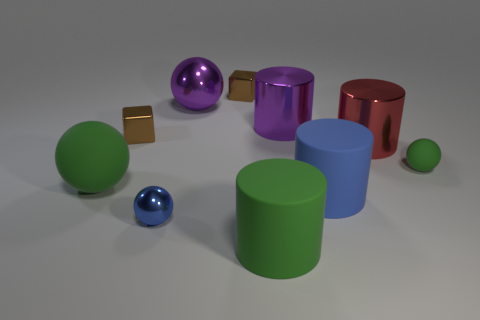There is a big cylinder that is the same color as the big shiny sphere; what material is it?
Make the answer very short. Metal. There is a object that is in front of the red thing and right of the blue cylinder; how big is it?
Give a very brief answer. Small. Is there a large cylinder in front of the green matte ball in front of the green rubber ball to the right of the blue metallic object?
Offer a very short reply. Yes. Are there any small cyan cylinders?
Your answer should be compact. No. Are there more green matte spheres on the right side of the large red shiny thing than big purple objects that are in front of the big purple metal cylinder?
Your answer should be compact. Yes. The other cylinder that is made of the same material as the green cylinder is what size?
Offer a very short reply. Large. What is the size of the brown shiny cube on the right side of the small sphere in front of the large sphere in front of the red thing?
Give a very brief answer. Small. The rubber ball right of the big red thing is what color?
Make the answer very short. Green. Are there more spheres that are on the left side of the big blue thing than tiny green objects?
Ensure brevity in your answer.  Yes. Do the metal object in front of the red metal cylinder and the blue matte thing have the same shape?
Give a very brief answer. No. 